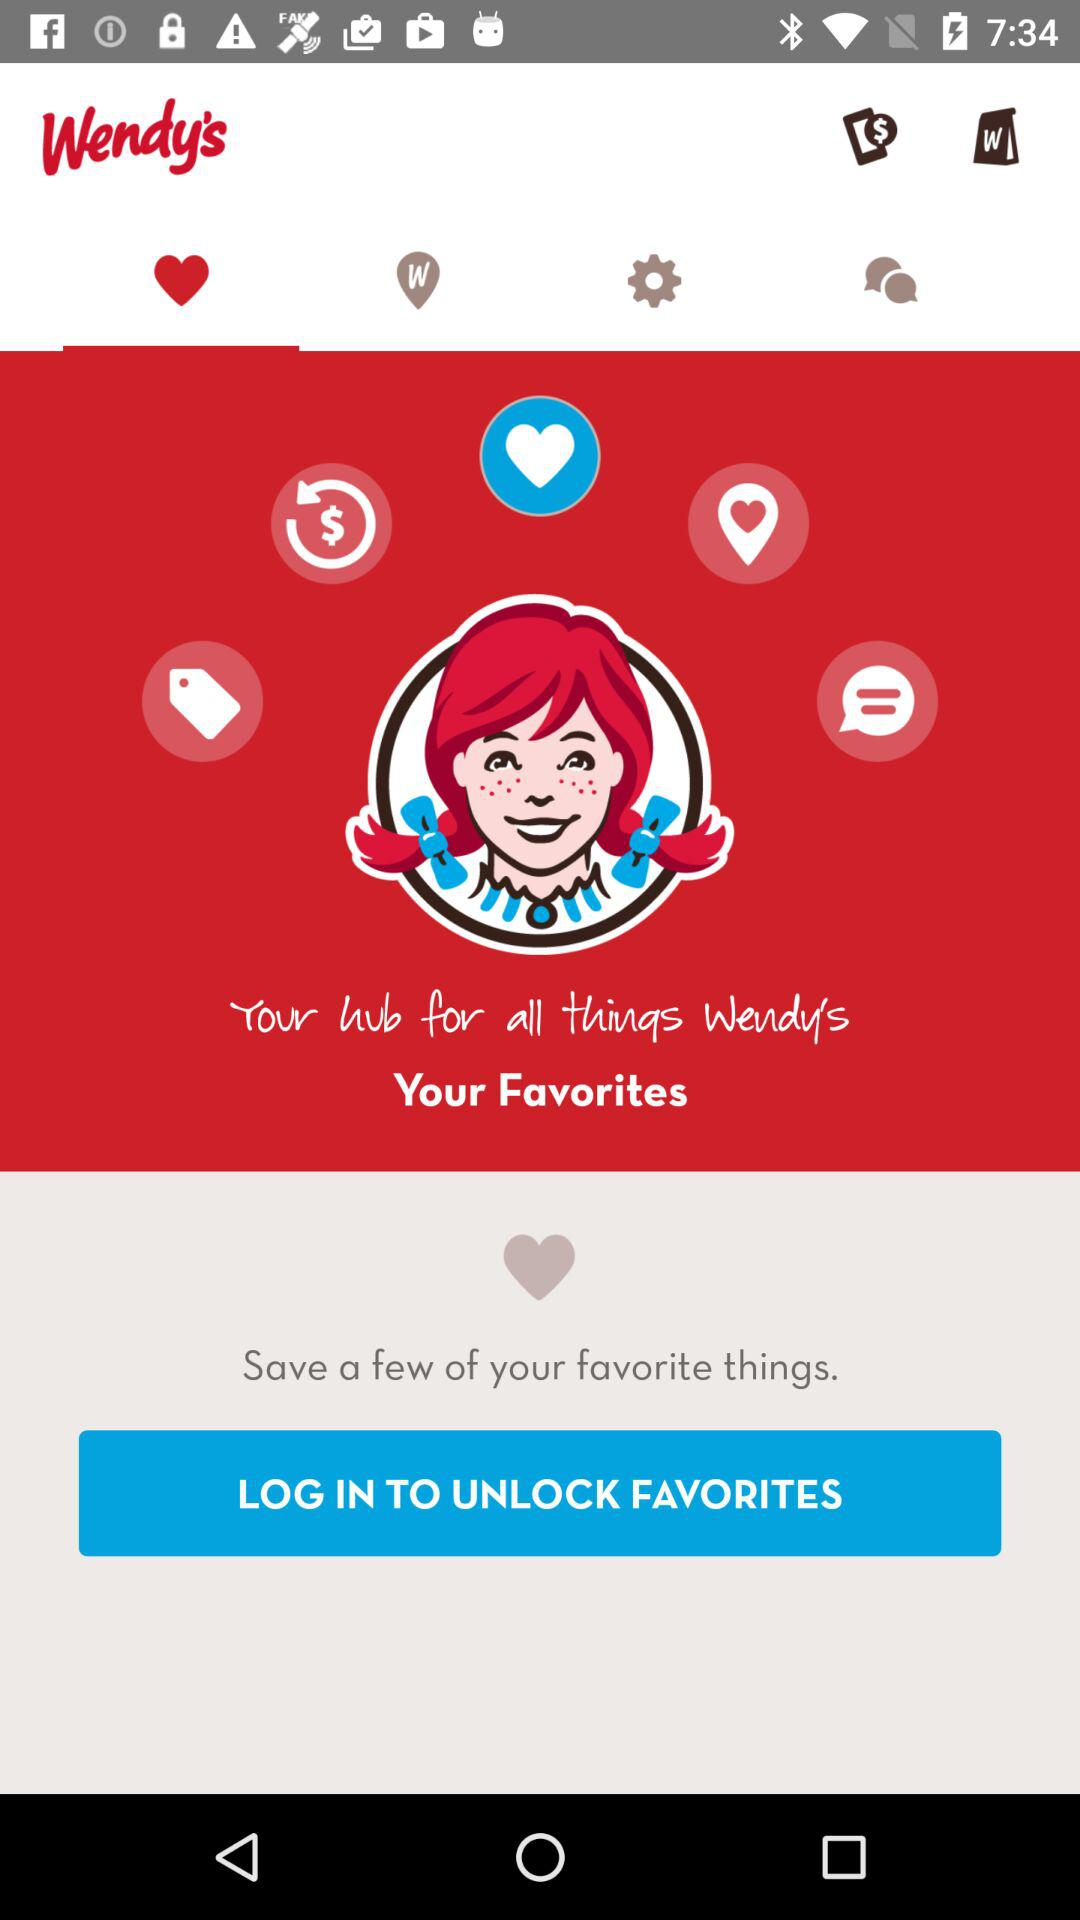Which products were saved as favorites?
When the provided information is insufficient, respond with <no answer>. <no answer> 